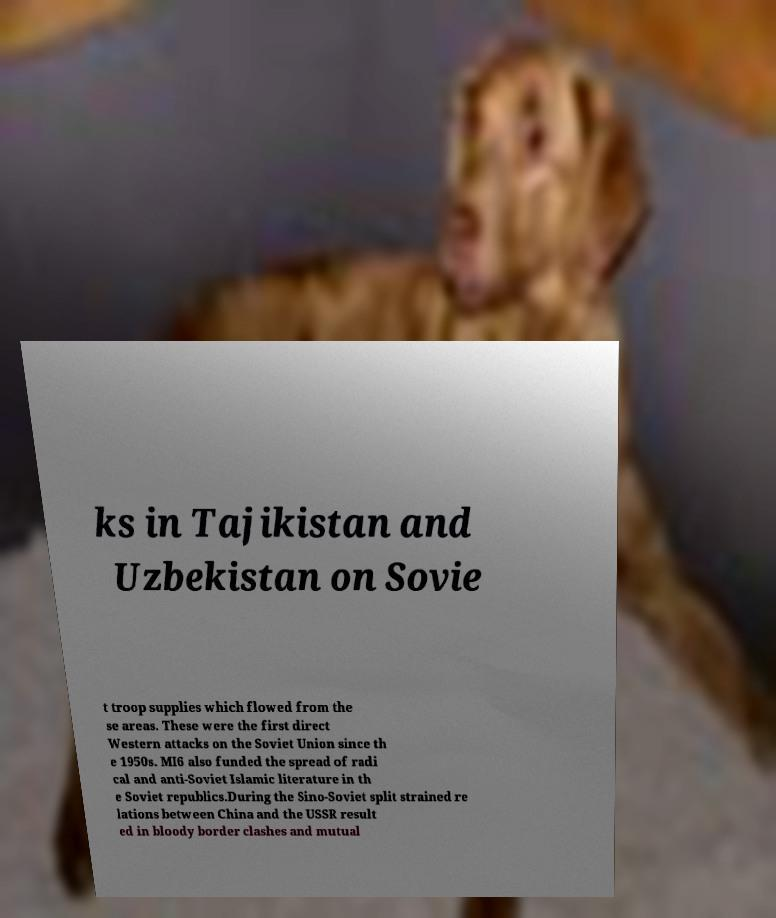Please identify and transcribe the text found in this image. ks in Tajikistan and Uzbekistan on Sovie t troop supplies which flowed from the se areas. These were the first direct Western attacks on the Soviet Union since th e 1950s. MI6 also funded the spread of radi cal and anti-Soviet Islamic literature in th e Soviet republics.During the Sino-Soviet split strained re lations between China and the USSR result ed in bloody border clashes and mutual 